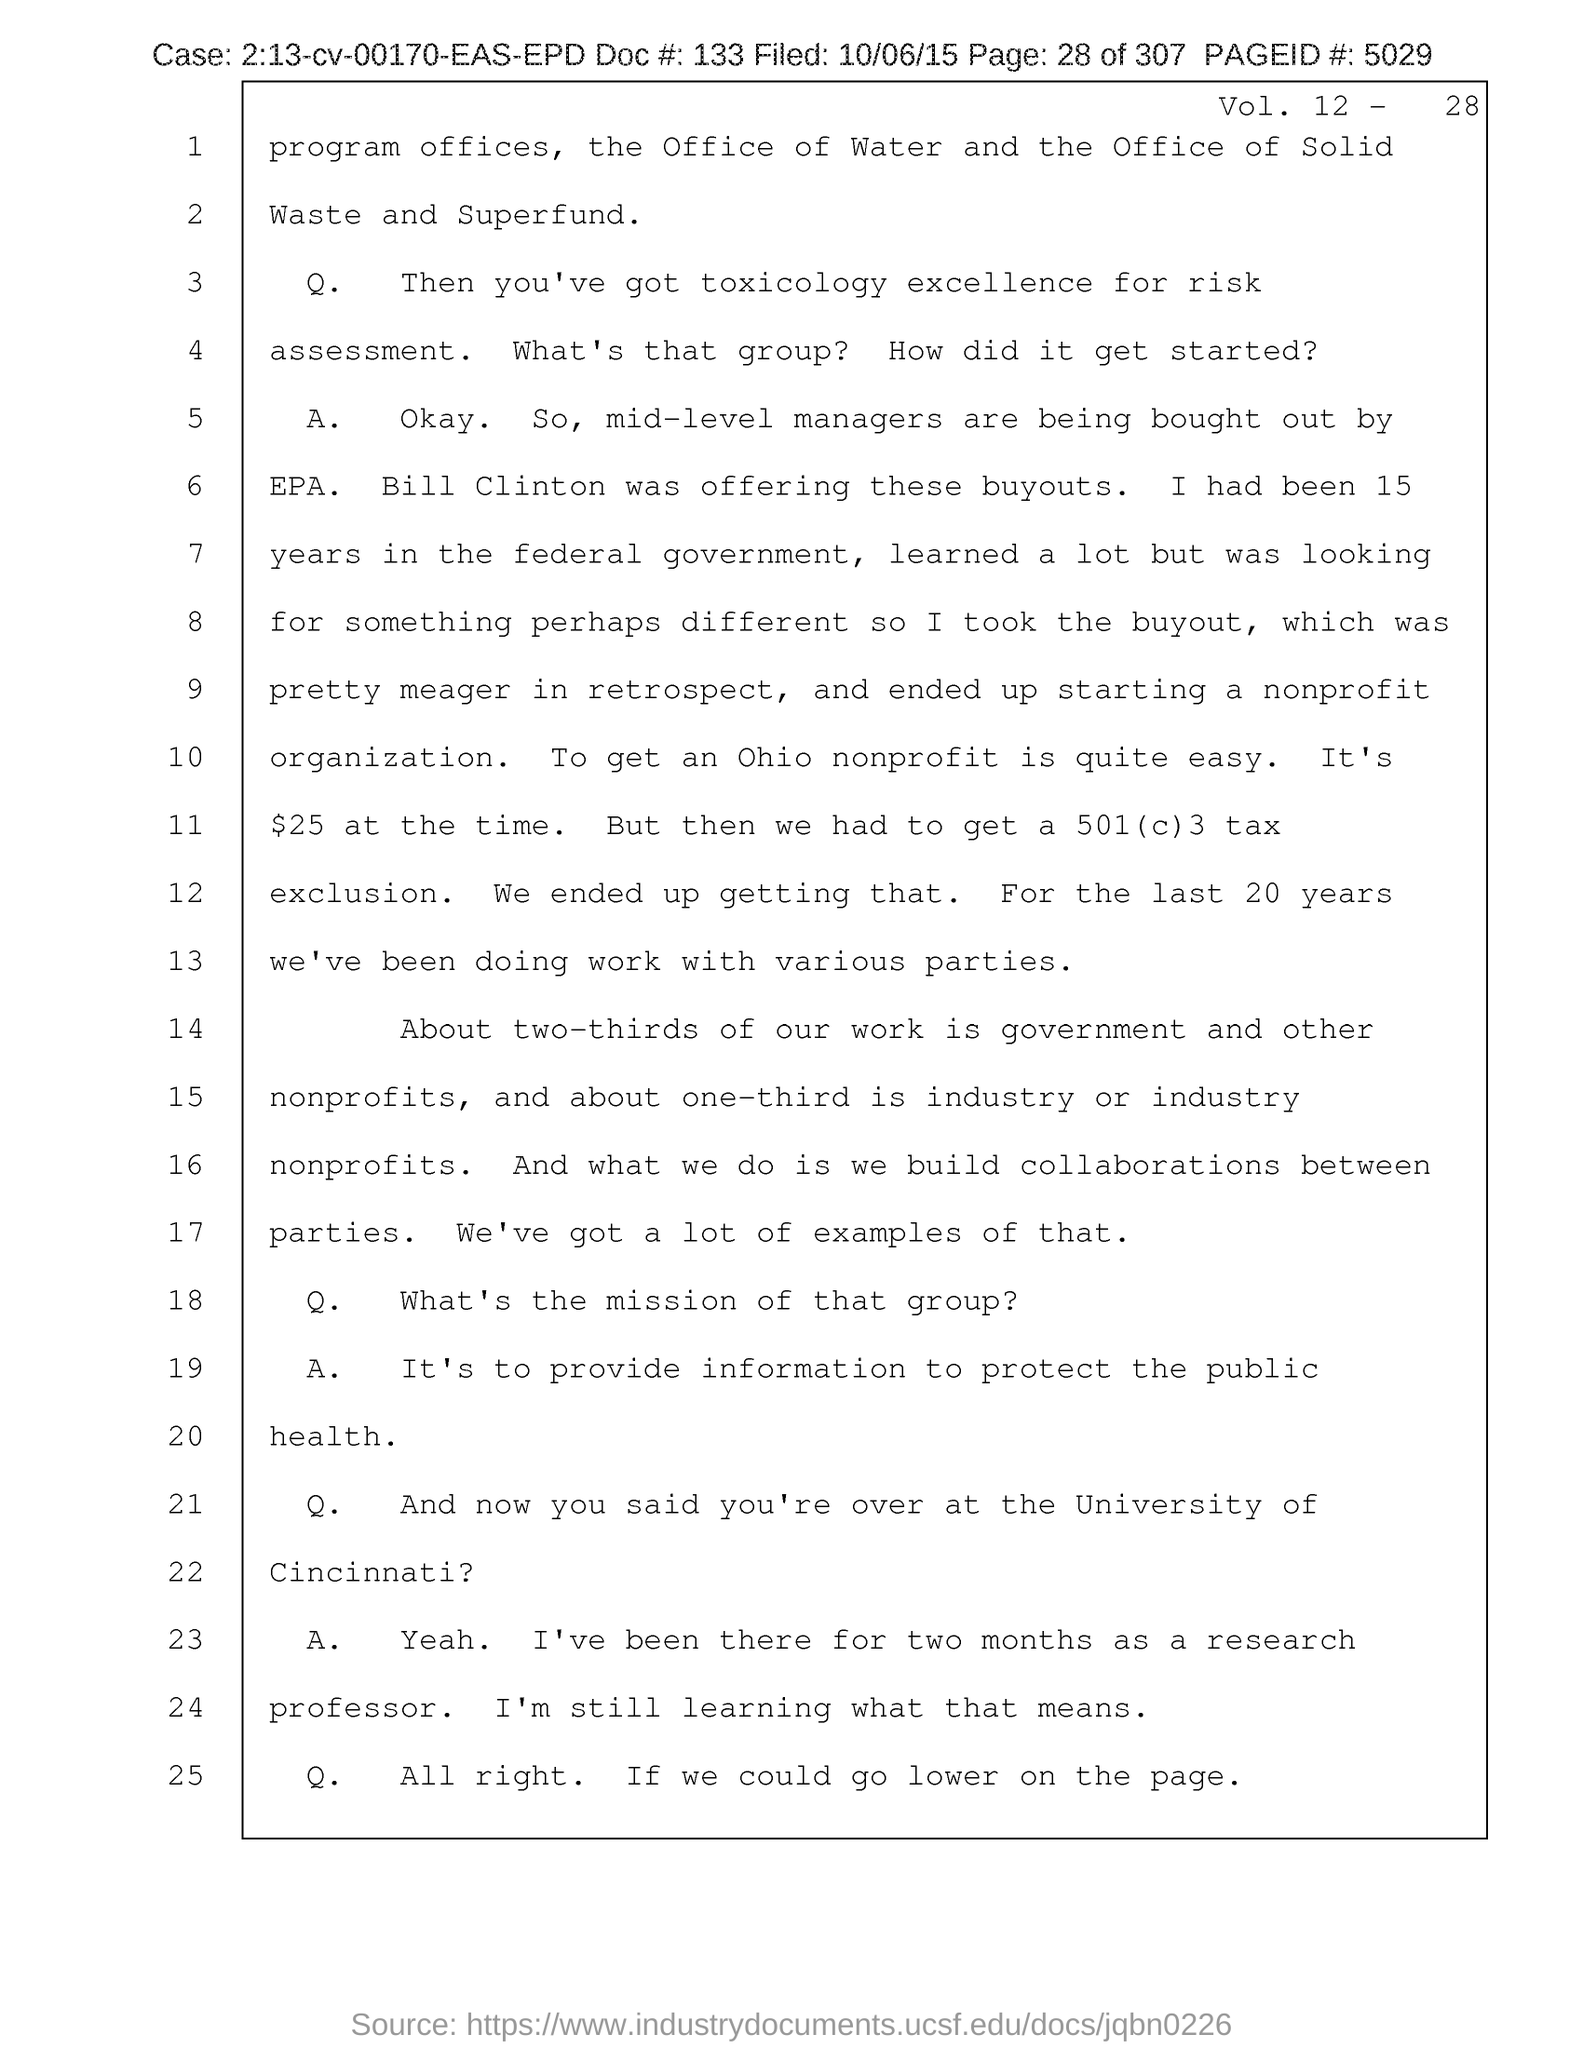Highlight a few significant elements in this photo. The field date of the document is October 6, 2015. The volume number provided in the document is 12-28. The document contains a Page ID number of 5029. The number provided in the document is 133. The page number mentioned in this document is 28 out of 307. 